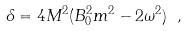Convert formula to latex. <formula><loc_0><loc_0><loc_500><loc_500>\delta = 4 M ^ { 2 } ( B _ { 0 } ^ { 2 } m ^ { 2 } - 2 \omega ^ { 2 } ) \ ,</formula> 